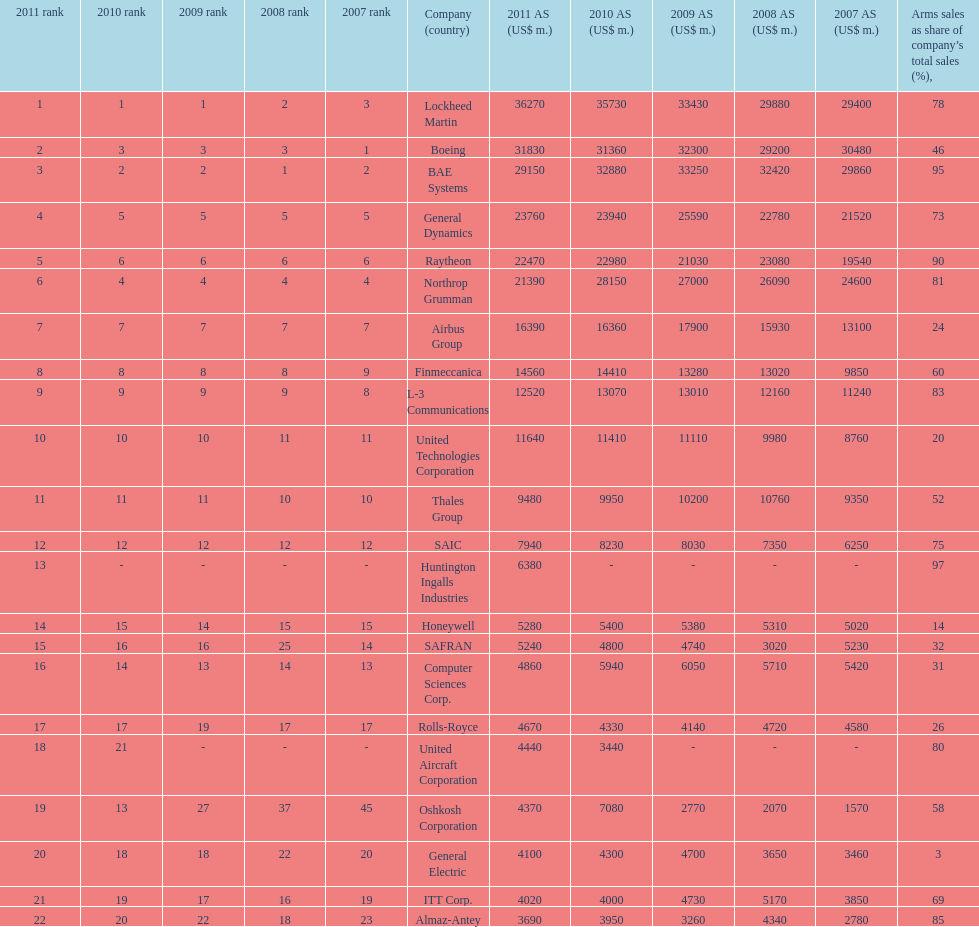In 2010, who has the least amount of sales? United Aircraft Corporation. 